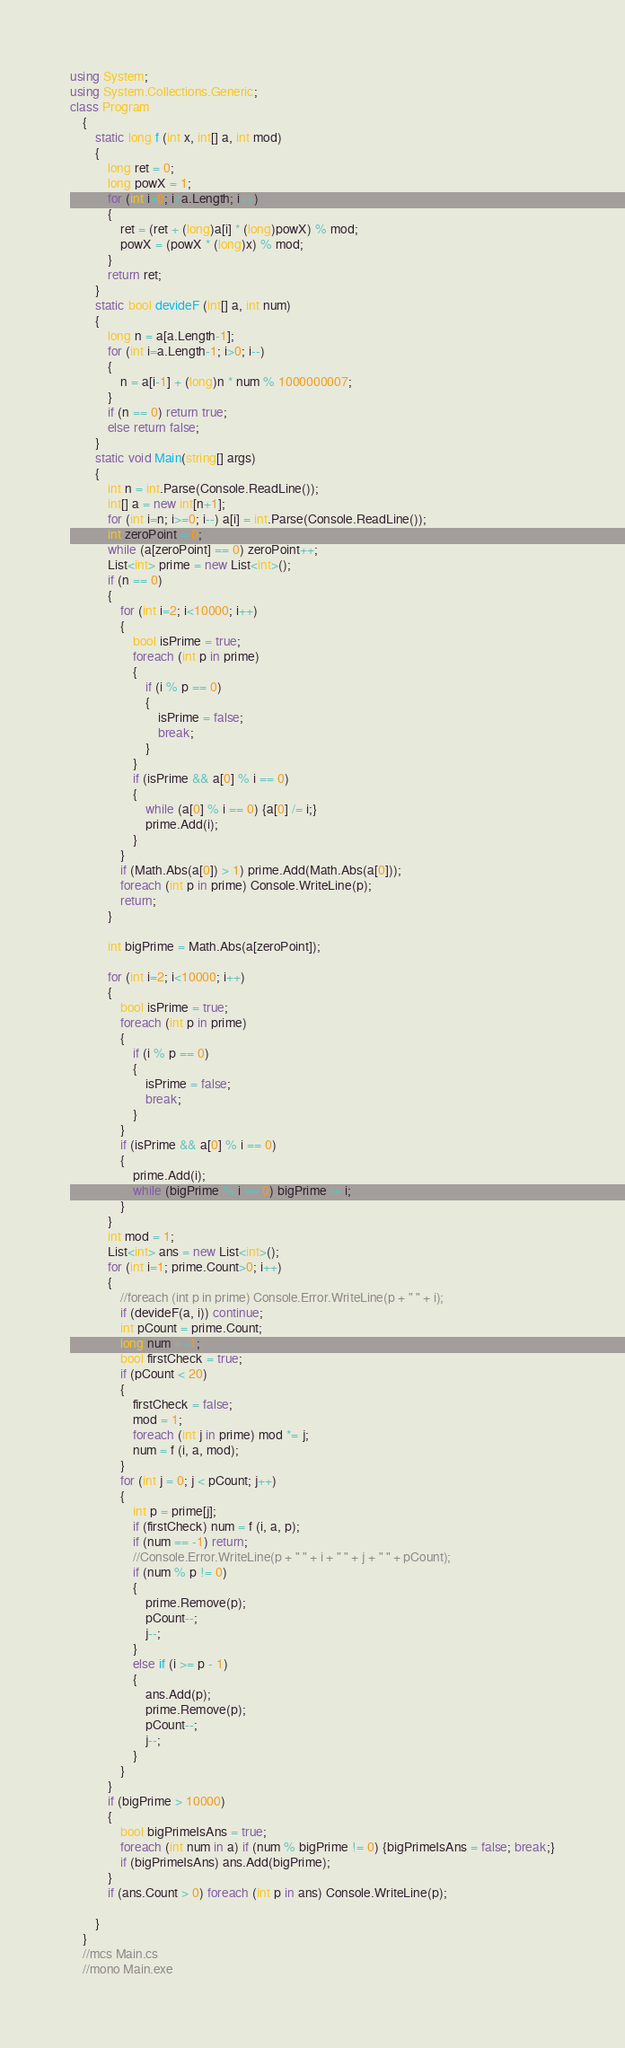<code> <loc_0><loc_0><loc_500><loc_500><_C#_>using System;
using System.Collections.Generic;
class Program
    {
        static long f (int x, int[] a, int mod)
        {
            long ret = 0;
            long powX = 1;
            for (int i=0; i<a.Length; i++)
            {
                ret = (ret + (long)a[i] * (long)powX) % mod;
                powX = (powX * (long)x) % mod;
            }
            return ret;
        }
        static bool devideF (int[] a, int num)
        {
            long n = a[a.Length-1];
            for (int i=a.Length-1; i>0; i--)
            {
                n = a[i-1] + (long)n * num % 1000000007;
            }
            if (n == 0) return true;
            else return false;
        }
        static void Main(string[] args)
        {
            int n = int.Parse(Console.ReadLine());
            int[] a = new int[n+1];
            for (int i=n; i>=0; i--) a[i] = int.Parse(Console.ReadLine());
            int zeroPoint = 0;
            while (a[zeroPoint] == 0) zeroPoint++;
            List<int> prime = new List<int>();
            if (n == 0)
            {
                for (int i=2; i<10000; i++)
                {
                    bool isPrime = true;
                    foreach (int p in prime)
                    {
                        if (i % p == 0)
                        {
                            isPrime = false;
                            break;
                        }
                    }
                    if (isPrime && a[0] % i == 0)
                    {
                        while (a[0] % i == 0) {a[0] /= i;}
                        prime.Add(i);
                    }
                }
                if (Math.Abs(a[0]) > 1) prime.Add(Math.Abs(a[0]));
                foreach (int p in prime) Console.WriteLine(p);
                return;
            }

            int bigPrime = Math.Abs(a[zeroPoint]);

            for (int i=2; i<10000; i++)
            {
                bool isPrime = true;
                foreach (int p in prime)
                {
                    if (i % p == 0)
                    {
                        isPrime = false;
                        break;
                    }
                }
                if (isPrime && a[0] % i == 0) 
                {
                    prime.Add(i);
                    while (bigPrime % i == 0) bigPrime /= i;
                }
            }
            int mod = 1;
            List<int> ans = new List<int>();
            for (int i=1; prime.Count>0; i++)
            {
                //foreach (int p in prime) Console.Error.WriteLine(p + " " + i);
                if (devideF(a, i)) continue;
                int pCount = prime.Count;
                long num = -1;
                bool firstCheck = true;
                if (pCount < 20)
                {
                    firstCheck = false;
                    mod = 1;
                    foreach (int j in prime) mod *= j;
                    num = f (i, a, mod);
                }
                for (int j = 0; j < pCount; j++)
                {
                    int p = prime[j];
                    if (firstCheck) num = f (i, a, p);
                    if (num == -1) return;
                    //Console.Error.WriteLine(p + " " + i + " " + j + " " + pCount);
                    if (num % p != 0)
                    {
                        prime.Remove(p);
                        pCount--;
                        j--;
                    }
                    else if (i >= p - 1)
                    {
                        ans.Add(p);
                        prime.Remove(p);
                        pCount--;
                        j--;
                    }
                }
            }
            if (bigPrime > 10000)
            {
                bool bigPrimeIsAns = true;
                foreach (int num in a) if (num % bigPrime != 0) {bigPrimeIsAns = false; break;}
                if (bigPrimeIsAns) ans.Add(bigPrime);
            }
            if (ans.Count > 0) foreach (int p in ans) Console.WriteLine(p);
            
        }
    }
    //mcs Main.cs
    //mono Main.exe</code> 